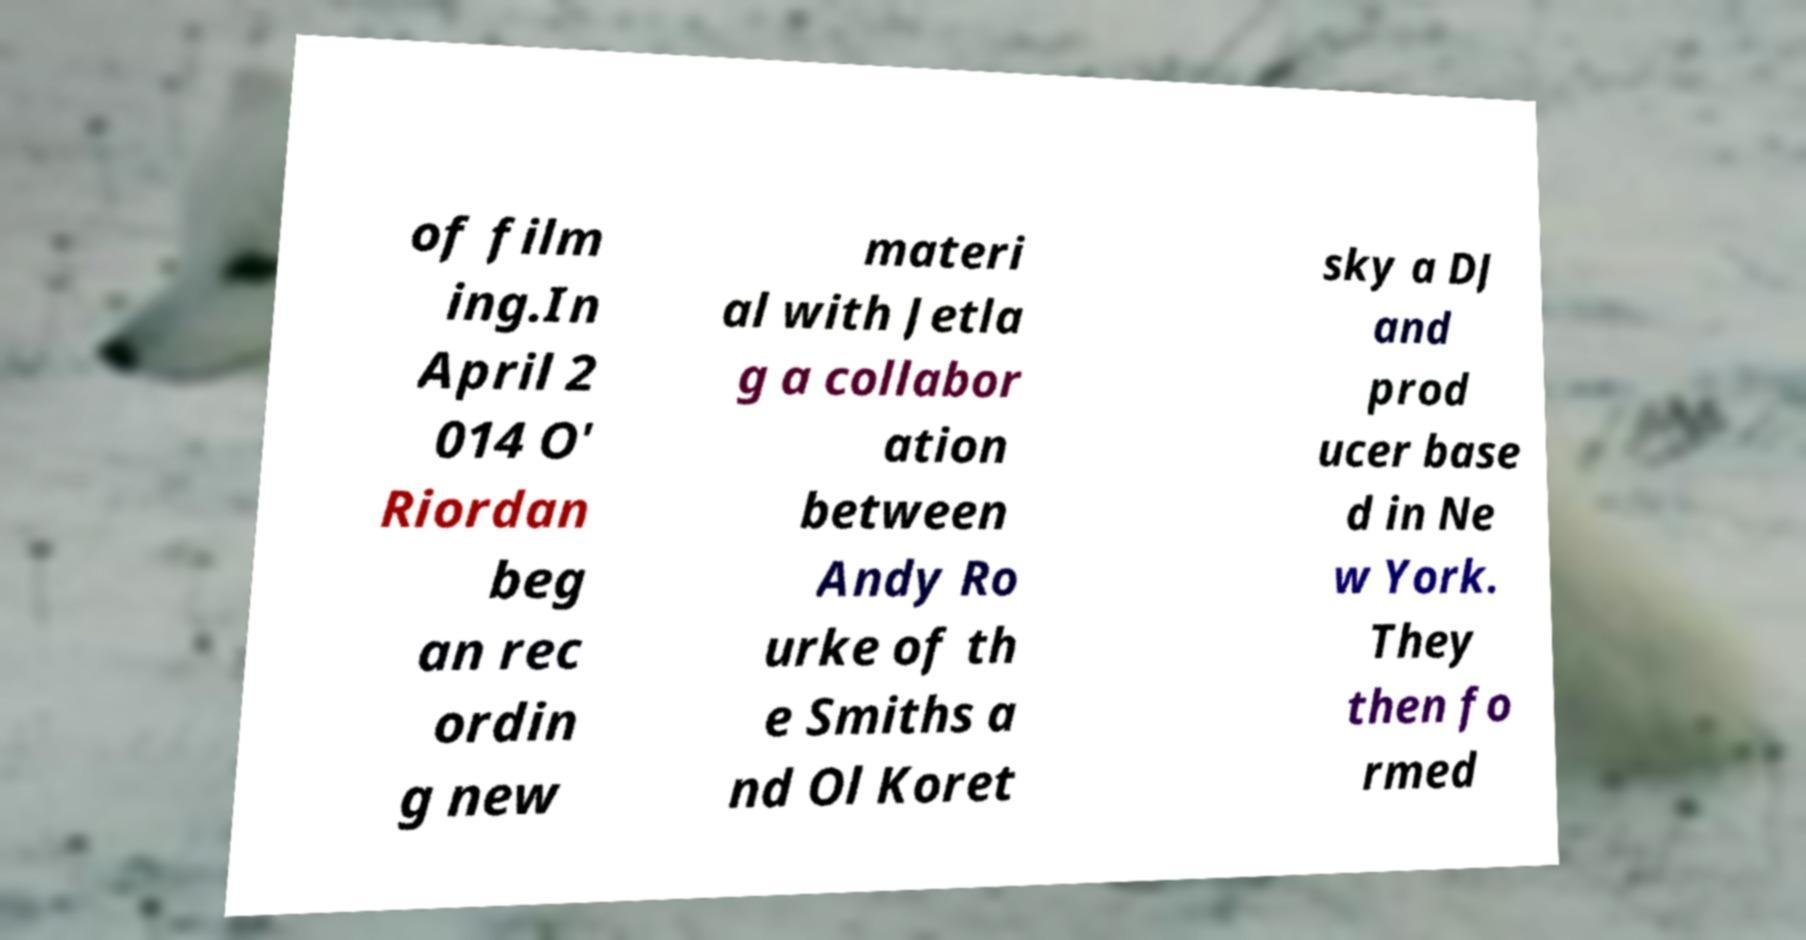What messages or text are displayed in this image? I need them in a readable, typed format. of film ing.In April 2 014 O' Riordan beg an rec ordin g new materi al with Jetla g a collabor ation between Andy Ro urke of th e Smiths a nd Ol Koret sky a DJ and prod ucer base d in Ne w York. They then fo rmed 